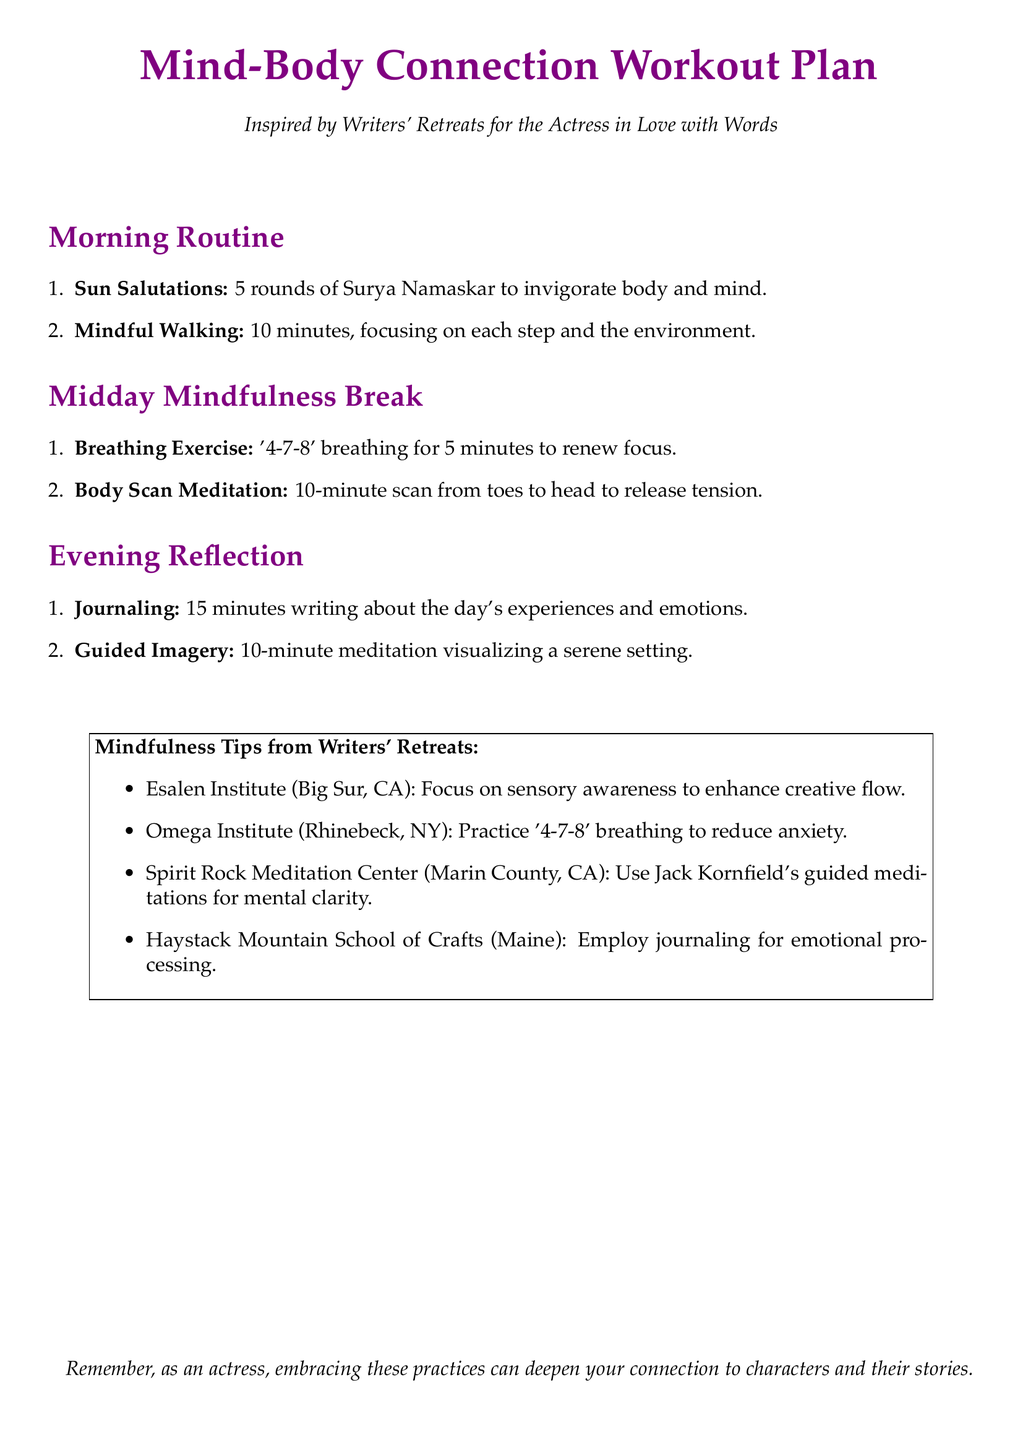What is the title of the document? The title is prominently displayed at the top of the document.
Answer: Mind-Body Connection Workout Plan How long should the Breathing Exercise last? The document specifies the duration for each activity.
Answer: 5 minutes What is the recommended number of rounds for Sun Salutations? It states the exact number of rounds advised in the Morning Routine section.
Answer: 5 rounds What meditation technique is suggested for the Evening Reflection? This is mentioned in the Evening Reflection section as a key activity.
Answer: Guided Imagery Which location focuses on sensory awareness? This information is included in the Mindfulness Tips section, detailing various retreat practices.
Answer: Esalen Institute What is the total duration of the Midday Mindfulness Break? The document provides time allocations for each activity in that section.
Answer: 15 minutes How many minutes should be dedicated to Journaling? This is specified in the Evening Reflection section of the document.
Answer: 15 minutes Which writer's retreat is associated with reducing anxiety? This is explicitly listed in the Mindfulness Tips from Writers' Retreats section.
Answer: Omega Institute What two practices are suggested in the Midday Mindfulness Break? The document outlines two specific activities in this section.
Answer: Breathing Exercise, Body Scan Meditation 